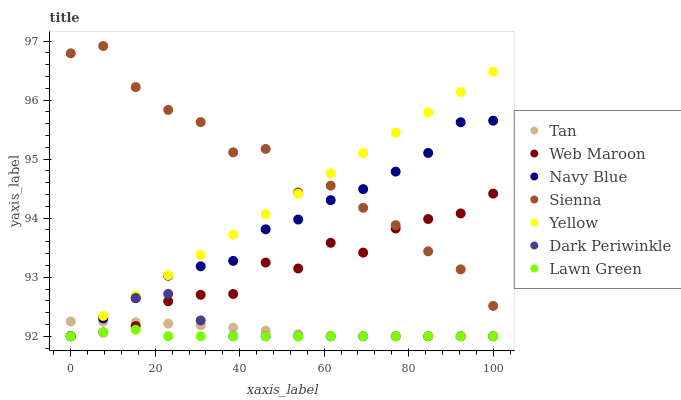Does Lawn Green have the minimum area under the curve?
Answer yes or no. Yes. Does Sienna have the maximum area under the curve?
Answer yes or no. Yes. Does Navy Blue have the minimum area under the curve?
Answer yes or no. No. Does Navy Blue have the maximum area under the curve?
Answer yes or no. No. Is Yellow the smoothest?
Answer yes or no. Yes. Is Sienna the roughest?
Answer yes or no. Yes. Is Navy Blue the smoothest?
Answer yes or no. No. Is Navy Blue the roughest?
Answer yes or no. No. Does Lawn Green have the lowest value?
Answer yes or no. Yes. Does Navy Blue have the lowest value?
Answer yes or no. No. Does Sienna have the highest value?
Answer yes or no. Yes. Does Navy Blue have the highest value?
Answer yes or no. No. Is Tan less than Sienna?
Answer yes or no. Yes. Is Sienna greater than Lawn Green?
Answer yes or no. Yes. Does Yellow intersect Dark Periwinkle?
Answer yes or no. Yes. Is Yellow less than Dark Periwinkle?
Answer yes or no. No. Is Yellow greater than Dark Periwinkle?
Answer yes or no. No. Does Tan intersect Sienna?
Answer yes or no. No. 